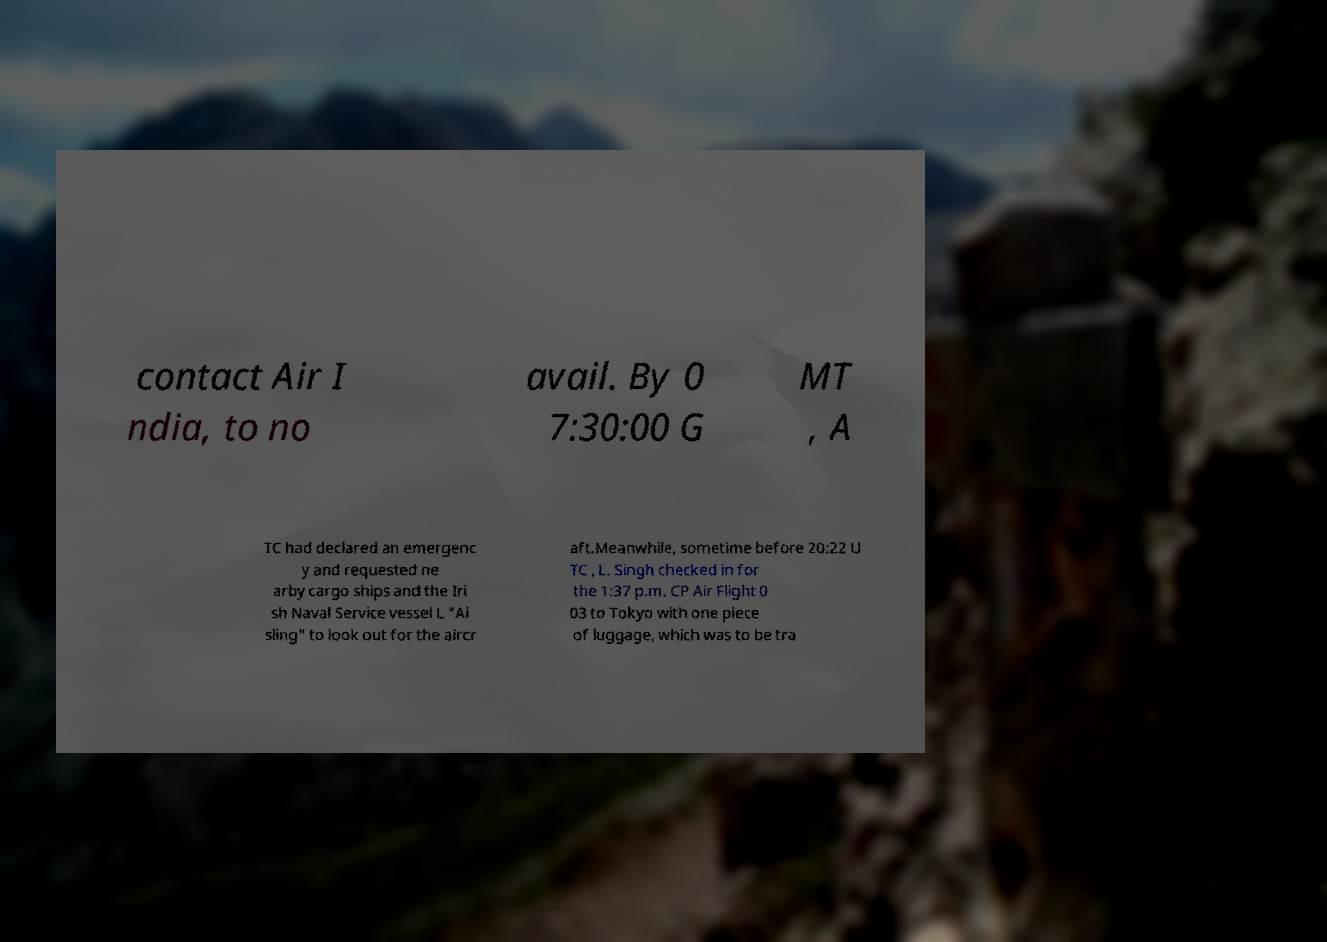Can you accurately transcribe the text from the provided image for me? contact Air I ndia, to no avail. By 0 7:30:00 G MT , A TC had declared an emergenc y and requested ne arby cargo ships and the Iri sh Naval Service vessel L "Ai sling" to look out for the aircr aft.Meanwhile, sometime before 20:22 U TC , L. Singh checked in for the 1:37 p.m. CP Air Flight 0 03 to Tokyo with one piece of luggage, which was to be tra 